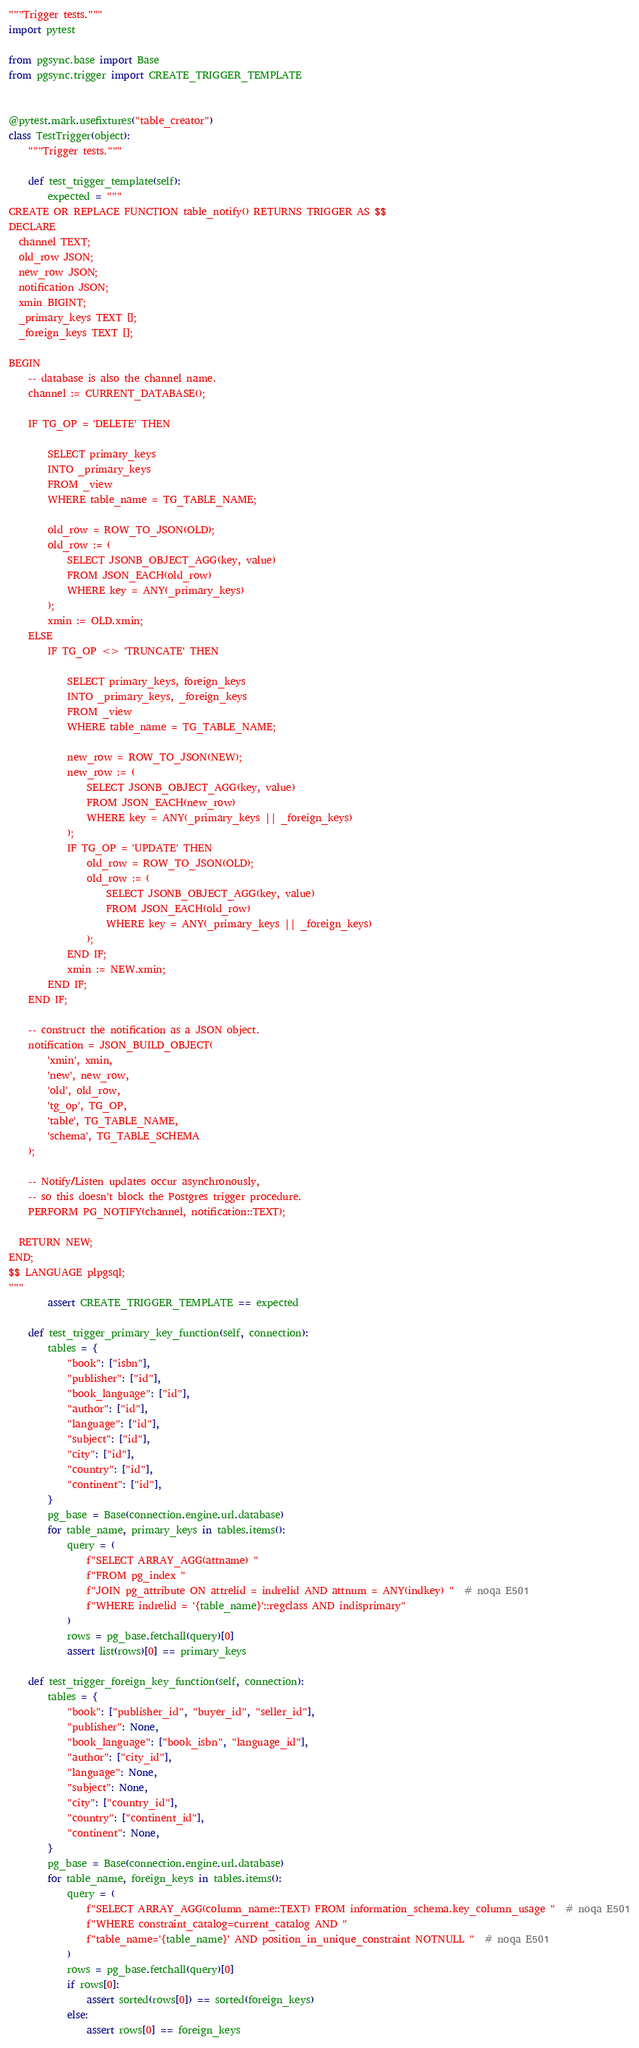Convert code to text. <code><loc_0><loc_0><loc_500><loc_500><_Python_>"""Trigger tests."""
import pytest

from pgsync.base import Base
from pgsync.trigger import CREATE_TRIGGER_TEMPLATE


@pytest.mark.usefixtures("table_creator")
class TestTrigger(object):
    """Trigger tests."""

    def test_trigger_template(self):
        expected = """
CREATE OR REPLACE FUNCTION table_notify() RETURNS TRIGGER AS $$
DECLARE
  channel TEXT;
  old_row JSON;
  new_row JSON;
  notification JSON;
  xmin BIGINT;
  _primary_keys TEXT [];
  _foreign_keys TEXT [];

BEGIN
    -- database is also the channel name.
    channel := CURRENT_DATABASE();

    IF TG_OP = 'DELETE' THEN

        SELECT primary_keys
        INTO _primary_keys
        FROM _view
        WHERE table_name = TG_TABLE_NAME;

        old_row = ROW_TO_JSON(OLD);
        old_row := (
            SELECT JSONB_OBJECT_AGG(key, value)
            FROM JSON_EACH(old_row)
            WHERE key = ANY(_primary_keys)
        );
        xmin := OLD.xmin;
    ELSE
        IF TG_OP <> 'TRUNCATE' THEN

            SELECT primary_keys, foreign_keys
            INTO _primary_keys, _foreign_keys
            FROM _view
            WHERE table_name = TG_TABLE_NAME;

            new_row = ROW_TO_JSON(NEW);
            new_row := (
                SELECT JSONB_OBJECT_AGG(key, value)
                FROM JSON_EACH(new_row)
                WHERE key = ANY(_primary_keys || _foreign_keys)
            );
            IF TG_OP = 'UPDATE' THEN
                old_row = ROW_TO_JSON(OLD);
                old_row := (
                    SELECT JSONB_OBJECT_AGG(key, value)
                    FROM JSON_EACH(old_row)
                    WHERE key = ANY(_primary_keys || _foreign_keys)
                );
            END IF;
            xmin := NEW.xmin;
        END IF;
    END IF;

    -- construct the notification as a JSON object.
    notification = JSON_BUILD_OBJECT(
        'xmin', xmin,
        'new', new_row,
        'old', old_row,
        'tg_op', TG_OP,
        'table', TG_TABLE_NAME,
        'schema', TG_TABLE_SCHEMA
    );

    -- Notify/Listen updates occur asynchronously,
    -- so this doesn't block the Postgres trigger procedure.
    PERFORM PG_NOTIFY(channel, notification::TEXT);

  RETURN NEW;
END;
$$ LANGUAGE plpgsql;
"""
        assert CREATE_TRIGGER_TEMPLATE == expected

    def test_trigger_primary_key_function(self, connection):
        tables = {
            "book": ["isbn"],
            "publisher": ["id"],
            "book_language": ["id"],
            "author": ["id"],
            "language": ["id"],
            "subject": ["id"],
            "city": ["id"],
            "country": ["id"],
            "continent": ["id"],
        }
        pg_base = Base(connection.engine.url.database)
        for table_name, primary_keys in tables.items():
            query = (
                f"SELECT ARRAY_AGG(attname) "
                f"FROM pg_index "
                f"JOIN pg_attribute ON attrelid = indrelid AND attnum = ANY(indkey) "  # noqa E501
                f"WHERE indrelid = '{table_name}'::regclass AND indisprimary"
            )
            rows = pg_base.fetchall(query)[0]
            assert list(rows)[0] == primary_keys

    def test_trigger_foreign_key_function(self, connection):
        tables = {
            "book": ["publisher_id", "buyer_id", "seller_id"],
            "publisher": None,
            "book_language": ["book_isbn", "language_id"],
            "author": ["city_id"],
            "language": None,
            "subject": None,
            "city": ["country_id"],
            "country": ["continent_id"],
            "continent": None,
        }
        pg_base = Base(connection.engine.url.database)
        for table_name, foreign_keys in tables.items():
            query = (
                f"SELECT ARRAY_AGG(column_name::TEXT) FROM information_schema.key_column_usage "  # noqa E501
                f"WHERE constraint_catalog=current_catalog AND "
                f"table_name='{table_name}' AND position_in_unique_constraint NOTNULL "  # noqa E501
            )
            rows = pg_base.fetchall(query)[0]
            if rows[0]:
                assert sorted(rows[0]) == sorted(foreign_keys)
            else:
                assert rows[0] == foreign_keys
</code> 